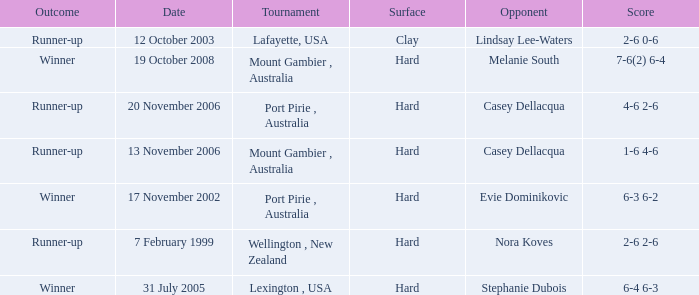When is an Opponent of evie dominikovic? 17 November 2002. 